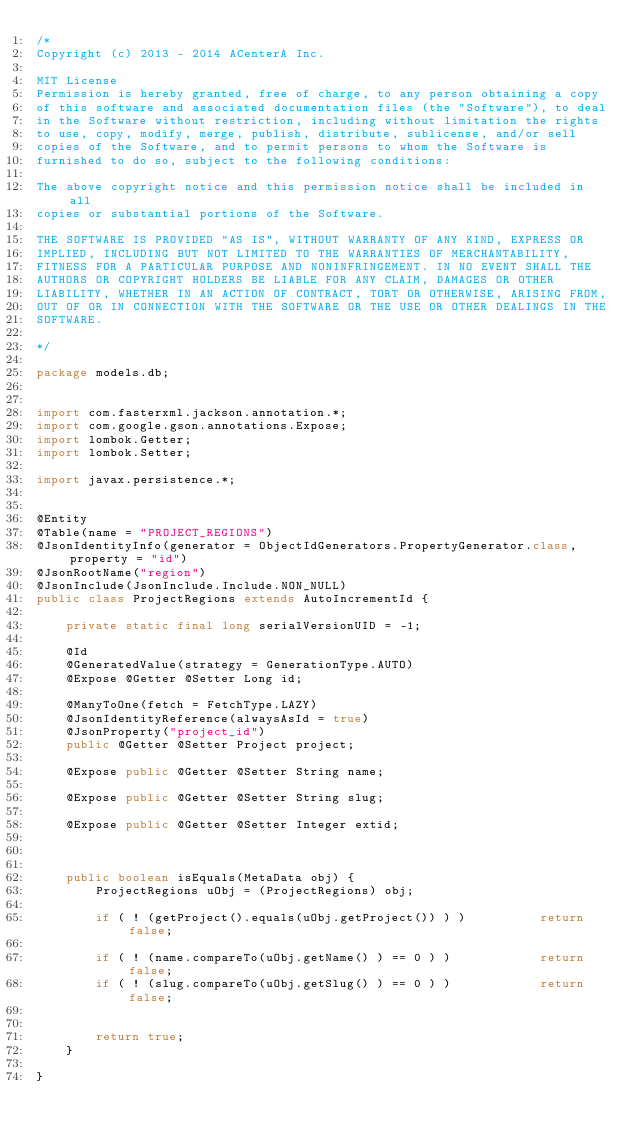<code> <loc_0><loc_0><loc_500><loc_500><_Java_>/*
Copyright (c) 2013 - 2014 ACenterA Inc.

MIT License
Permission is hereby granted, free of charge, to any person obtaining a copy
of this software and associated documentation files (the "Software"), to deal
in the Software without restriction, including without limitation the rights
to use, copy, modify, merge, publish, distribute, sublicense, and/or sell
copies of the Software, and to permit persons to whom the Software is
furnished to do so, subject to the following conditions:

The above copyright notice and this permission notice shall be included in all
copies or substantial portions of the Software.

THE SOFTWARE IS PROVIDED "AS IS", WITHOUT WARRANTY OF ANY KIND, EXPRESS OR
IMPLIED, INCLUDING BUT NOT LIMITED TO THE WARRANTIES OF MERCHANTABILITY,
FITNESS FOR A PARTICULAR PURPOSE AND NONINFRINGEMENT. IN NO EVENT SHALL THE
AUTHORS OR COPYRIGHT HOLDERS BE LIABLE FOR ANY CLAIM, DAMAGES OR OTHER
LIABILITY, WHETHER IN AN ACTION OF CONTRACT, TORT OR OTHERWISE, ARISING FROM,
OUT OF OR IN CONNECTION WITH THE SOFTWARE OR THE USE OR OTHER DEALINGS IN THE
SOFTWARE.

*/

package models.db;


import com.fasterxml.jackson.annotation.*;
import com.google.gson.annotations.Expose;
import lombok.Getter;
import lombok.Setter;

import javax.persistence.*;


@Entity
@Table(name = "PROJECT_REGIONS")
@JsonIdentityInfo(generator = ObjectIdGenerators.PropertyGenerator.class, property = "id")
@JsonRootName("region")
@JsonInclude(JsonInclude.Include.NON_NULL)
public class ProjectRegions extends AutoIncrementId {

    private static final long serialVersionUID = -1;

    @Id
    @GeneratedValue(strategy = GenerationType.AUTO)
    @Expose @Getter @Setter Long id;

    @ManyToOne(fetch = FetchType.LAZY)
    @JsonIdentityReference(alwaysAsId = true)
    @JsonProperty("project_id")
    public @Getter @Setter Project project;

    @Expose public @Getter @Setter String name;

    @Expose public @Getter @Setter String slug;

    @Expose public @Getter @Setter Integer extid;



    public boolean isEquals(MetaData obj) {
        ProjectRegions uObj = (ProjectRegions) obj;

        if ( ! (getProject().equals(uObj.getProject()) ) )          return false;

        if ( ! (name.compareTo(uObj.getName() ) == 0 ) )            return false;
        if ( ! (slug.compareTo(uObj.getSlug() ) == 0 ) )            return false;


        return true;
    }

}


</code> 